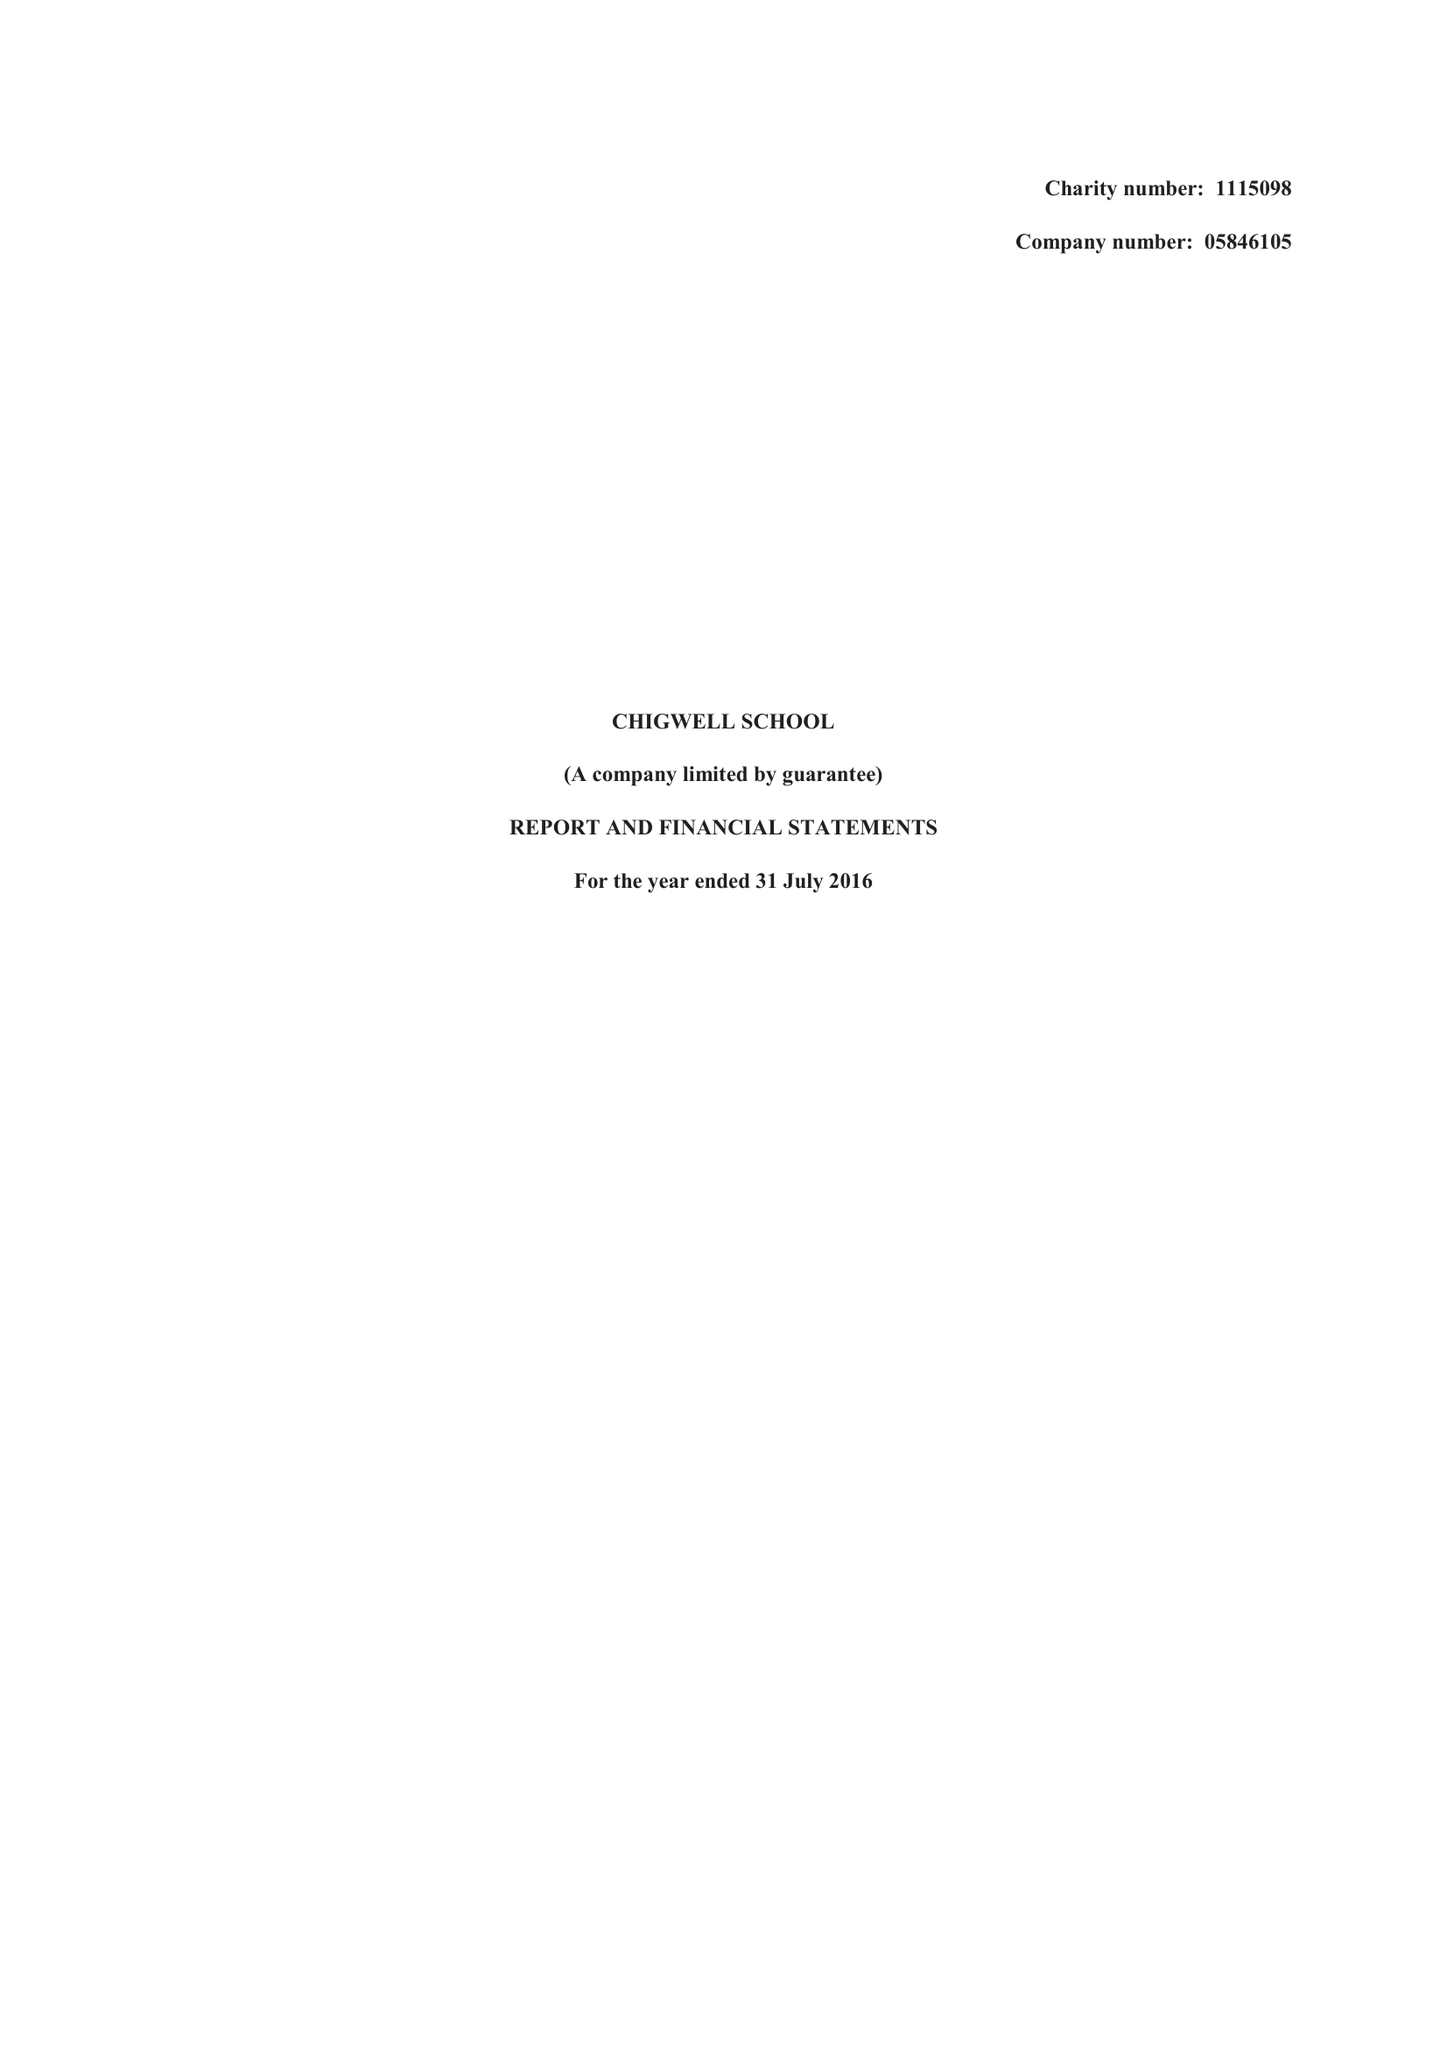What is the value for the charity_number?
Answer the question using a single word or phrase. 1115098 